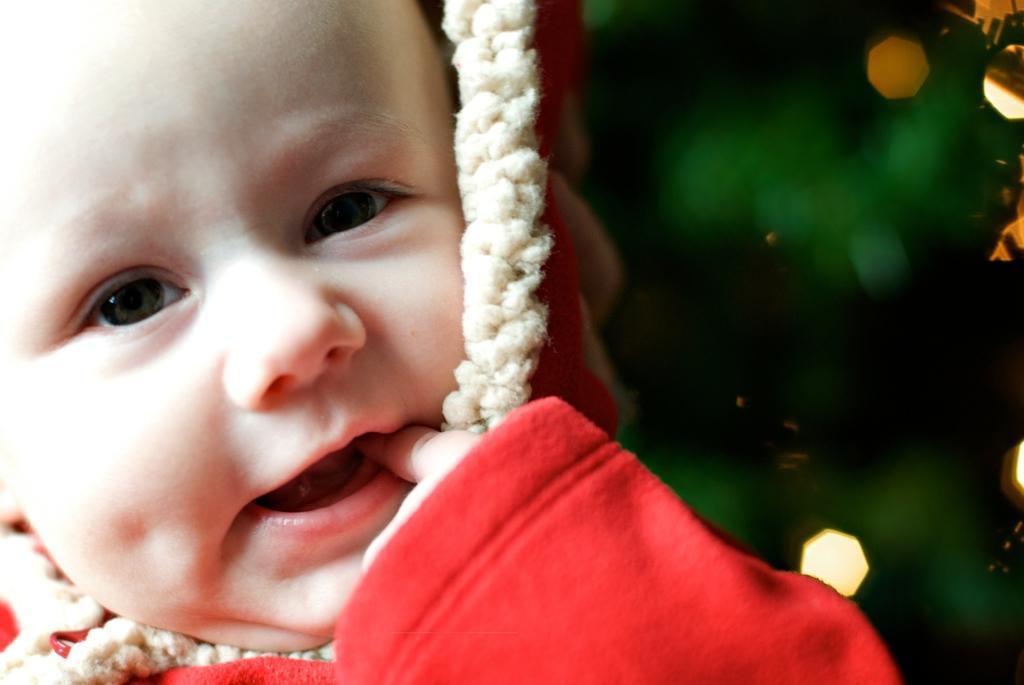Please provide a concise description of this image. Here in this picture we can see a baby present and she is wearing a red colored sweater on her and she is keeping fingers in her mouth. 